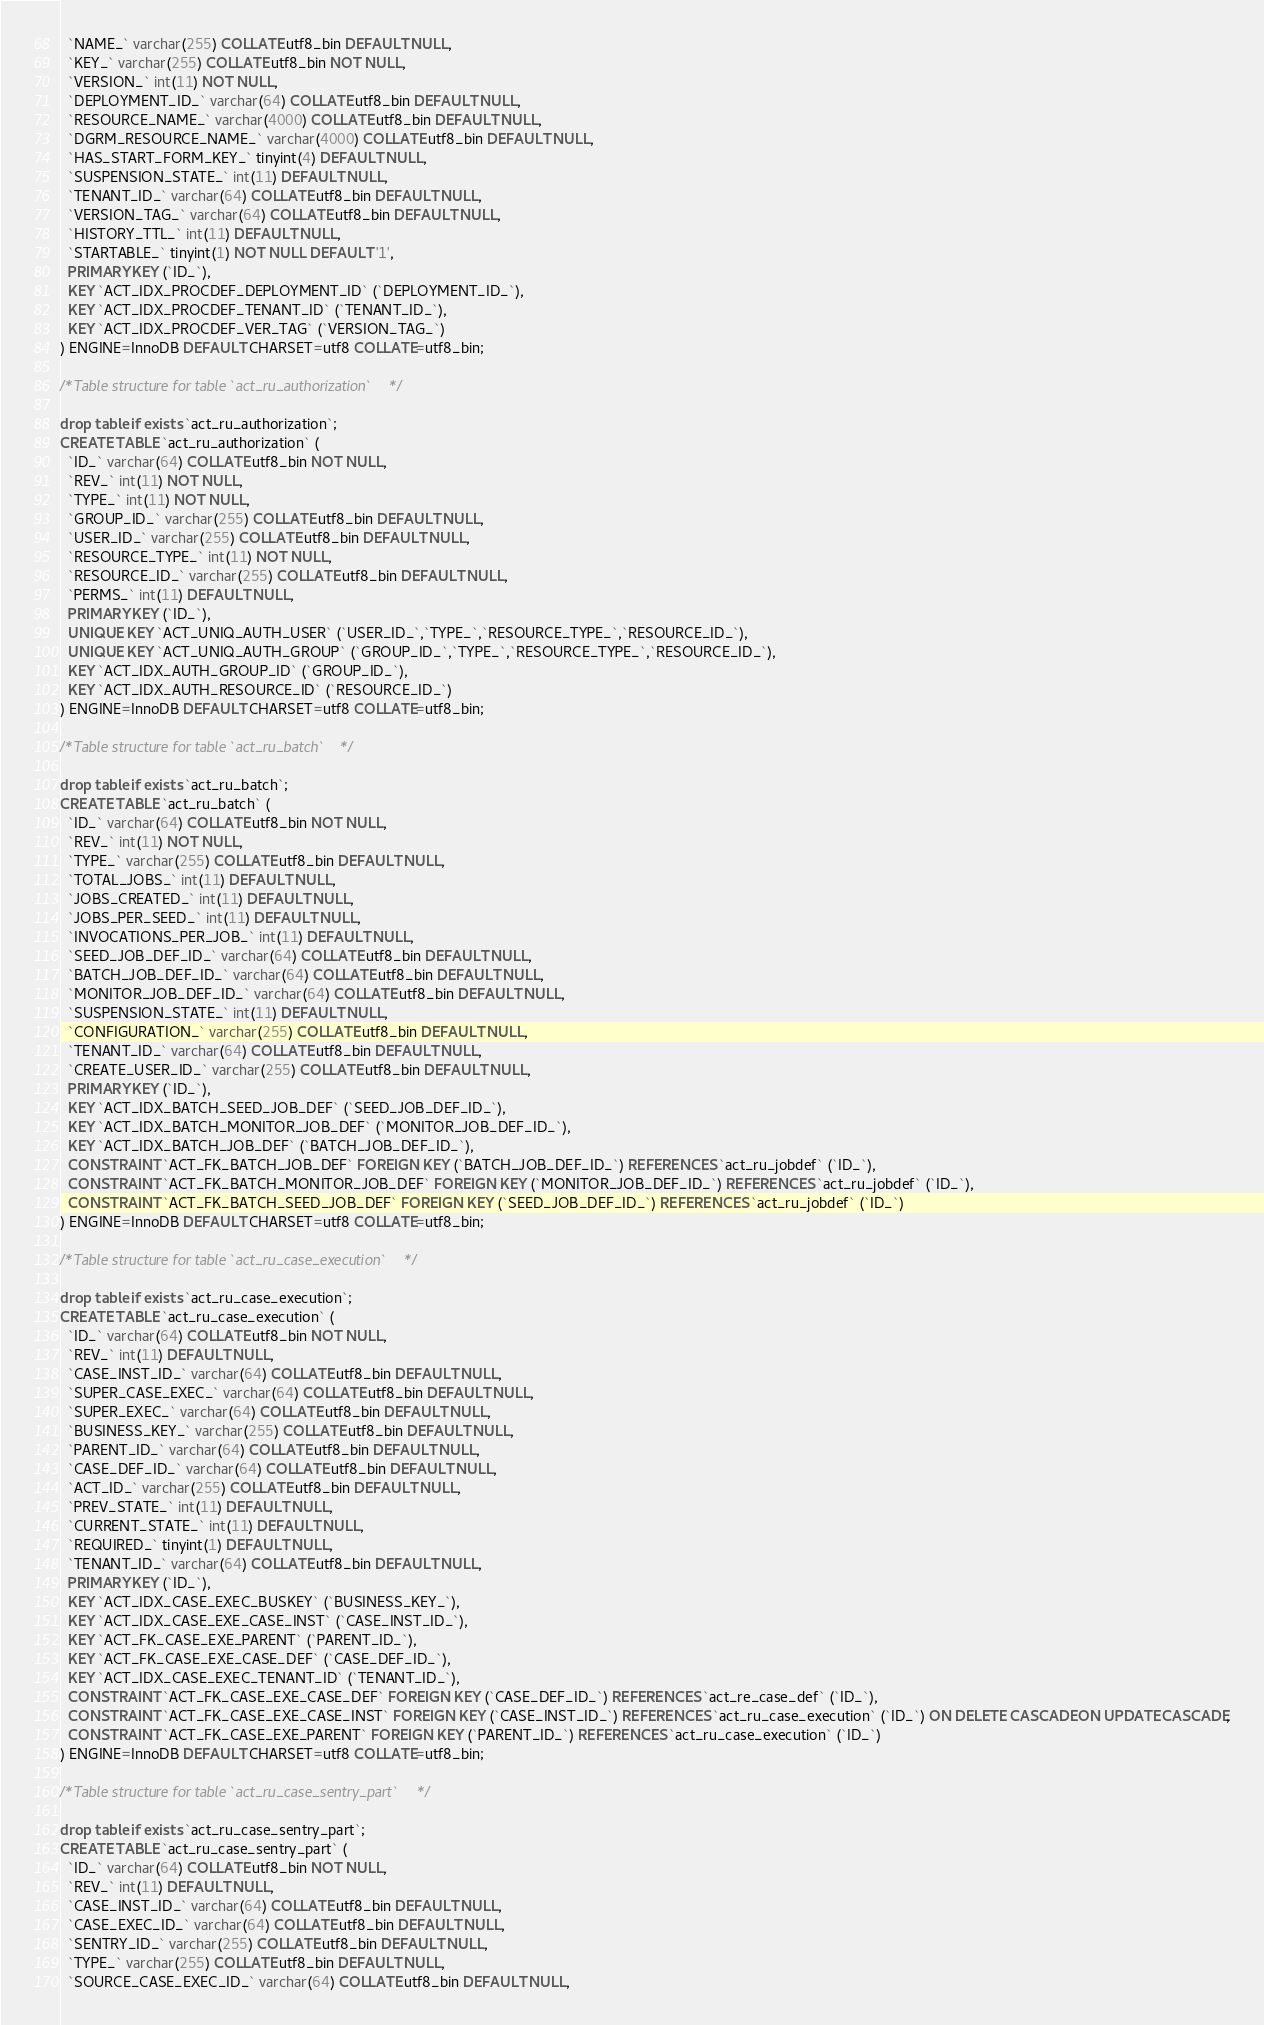Convert code to text. <code><loc_0><loc_0><loc_500><loc_500><_SQL_>  `NAME_` varchar(255) COLLATE utf8_bin DEFAULT NULL,
  `KEY_` varchar(255) COLLATE utf8_bin NOT NULL,
  `VERSION_` int(11) NOT NULL,
  `DEPLOYMENT_ID_` varchar(64) COLLATE utf8_bin DEFAULT NULL,
  `RESOURCE_NAME_` varchar(4000) COLLATE utf8_bin DEFAULT NULL,
  `DGRM_RESOURCE_NAME_` varchar(4000) COLLATE utf8_bin DEFAULT NULL,
  `HAS_START_FORM_KEY_` tinyint(4) DEFAULT NULL,
  `SUSPENSION_STATE_` int(11) DEFAULT NULL,
  `TENANT_ID_` varchar(64) COLLATE utf8_bin DEFAULT NULL,
  `VERSION_TAG_` varchar(64) COLLATE utf8_bin DEFAULT NULL,
  `HISTORY_TTL_` int(11) DEFAULT NULL,
  `STARTABLE_` tinyint(1) NOT NULL DEFAULT '1',
  PRIMARY KEY (`ID_`),
  KEY `ACT_IDX_PROCDEF_DEPLOYMENT_ID` (`DEPLOYMENT_ID_`),
  KEY `ACT_IDX_PROCDEF_TENANT_ID` (`TENANT_ID_`),
  KEY `ACT_IDX_PROCDEF_VER_TAG` (`VERSION_TAG_`)
) ENGINE=InnoDB DEFAULT CHARSET=utf8 COLLATE=utf8_bin;

/*Table structure for table `act_ru_authorization` */

drop table if exists `act_ru_authorization`;
CREATE TABLE `act_ru_authorization` (
  `ID_` varchar(64) COLLATE utf8_bin NOT NULL,
  `REV_` int(11) NOT NULL,
  `TYPE_` int(11) NOT NULL,
  `GROUP_ID_` varchar(255) COLLATE utf8_bin DEFAULT NULL,
  `USER_ID_` varchar(255) COLLATE utf8_bin DEFAULT NULL,
  `RESOURCE_TYPE_` int(11) NOT NULL,
  `RESOURCE_ID_` varchar(255) COLLATE utf8_bin DEFAULT NULL,
  `PERMS_` int(11) DEFAULT NULL,
  PRIMARY KEY (`ID_`),
  UNIQUE KEY `ACT_UNIQ_AUTH_USER` (`USER_ID_`,`TYPE_`,`RESOURCE_TYPE_`,`RESOURCE_ID_`),
  UNIQUE KEY `ACT_UNIQ_AUTH_GROUP` (`GROUP_ID_`,`TYPE_`,`RESOURCE_TYPE_`,`RESOURCE_ID_`),
  KEY `ACT_IDX_AUTH_GROUP_ID` (`GROUP_ID_`),
  KEY `ACT_IDX_AUTH_RESOURCE_ID` (`RESOURCE_ID_`)
) ENGINE=InnoDB DEFAULT CHARSET=utf8 COLLATE=utf8_bin;

/*Table structure for table `act_ru_batch` */

drop table if exists `act_ru_batch`;
CREATE TABLE `act_ru_batch` (
  `ID_` varchar(64) COLLATE utf8_bin NOT NULL,
  `REV_` int(11) NOT NULL,
  `TYPE_` varchar(255) COLLATE utf8_bin DEFAULT NULL,
  `TOTAL_JOBS_` int(11) DEFAULT NULL,
  `JOBS_CREATED_` int(11) DEFAULT NULL,
  `JOBS_PER_SEED_` int(11) DEFAULT NULL,
  `INVOCATIONS_PER_JOB_` int(11) DEFAULT NULL,
  `SEED_JOB_DEF_ID_` varchar(64) COLLATE utf8_bin DEFAULT NULL,
  `BATCH_JOB_DEF_ID_` varchar(64) COLLATE utf8_bin DEFAULT NULL,
  `MONITOR_JOB_DEF_ID_` varchar(64) COLLATE utf8_bin DEFAULT NULL,
  `SUSPENSION_STATE_` int(11) DEFAULT NULL,
  `CONFIGURATION_` varchar(255) COLLATE utf8_bin DEFAULT NULL,
  `TENANT_ID_` varchar(64) COLLATE utf8_bin DEFAULT NULL,
  `CREATE_USER_ID_` varchar(255) COLLATE utf8_bin DEFAULT NULL,
  PRIMARY KEY (`ID_`),
  KEY `ACT_IDX_BATCH_SEED_JOB_DEF` (`SEED_JOB_DEF_ID_`),
  KEY `ACT_IDX_BATCH_MONITOR_JOB_DEF` (`MONITOR_JOB_DEF_ID_`),
  KEY `ACT_IDX_BATCH_JOB_DEF` (`BATCH_JOB_DEF_ID_`),
  CONSTRAINT `ACT_FK_BATCH_JOB_DEF` FOREIGN KEY (`BATCH_JOB_DEF_ID_`) REFERENCES `act_ru_jobdef` (`ID_`),
  CONSTRAINT `ACT_FK_BATCH_MONITOR_JOB_DEF` FOREIGN KEY (`MONITOR_JOB_DEF_ID_`) REFERENCES `act_ru_jobdef` (`ID_`),
  CONSTRAINT `ACT_FK_BATCH_SEED_JOB_DEF` FOREIGN KEY (`SEED_JOB_DEF_ID_`) REFERENCES `act_ru_jobdef` (`ID_`)
) ENGINE=InnoDB DEFAULT CHARSET=utf8 COLLATE=utf8_bin;

/*Table structure for table `act_ru_case_execution` */

drop table if exists `act_ru_case_execution`;
CREATE TABLE `act_ru_case_execution` (
  `ID_` varchar(64) COLLATE utf8_bin NOT NULL,
  `REV_` int(11) DEFAULT NULL,
  `CASE_INST_ID_` varchar(64) COLLATE utf8_bin DEFAULT NULL,
  `SUPER_CASE_EXEC_` varchar(64) COLLATE utf8_bin DEFAULT NULL,
  `SUPER_EXEC_` varchar(64) COLLATE utf8_bin DEFAULT NULL,
  `BUSINESS_KEY_` varchar(255) COLLATE utf8_bin DEFAULT NULL,
  `PARENT_ID_` varchar(64) COLLATE utf8_bin DEFAULT NULL,
  `CASE_DEF_ID_` varchar(64) COLLATE utf8_bin DEFAULT NULL,
  `ACT_ID_` varchar(255) COLLATE utf8_bin DEFAULT NULL,
  `PREV_STATE_` int(11) DEFAULT NULL,
  `CURRENT_STATE_` int(11) DEFAULT NULL,
  `REQUIRED_` tinyint(1) DEFAULT NULL,
  `TENANT_ID_` varchar(64) COLLATE utf8_bin DEFAULT NULL,
  PRIMARY KEY (`ID_`),
  KEY `ACT_IDX_CASE_EXEC_BUSKEY` (`BUSINESS_KEY_`),
  KEY `ACT_IDX_CASE_EXE_CASE_INST` (`CASE_INST_ID_`),
  KEY `ACT_FK_CASE_EXE_PARENT` (`PARENT_ID_`),
  KEY `ACT_FK_CASE_EXE_CASE_DEF` (`CASE_DEF_ID_`),
  KEY `ACT_IDX_CASE_EXEC_TENANT_ID` (`TENANT_ID_`),
  CONSTRAINT `ACT_FK_CASE_EXE_CASE_DEF` FOREIGN KEY (`CASE_DEF_ID_`) REFERENCES `act_re_case_def` (`ID_`),
  CONSTRAINT `ACT_FK_CASE_EXE_CASE_INST` FOREIGN KEY (`CASE_INST_ID_`) REFERENCES `act_ru_case_execution` (`ID_`) ON DELETE CASCADE ON UPDATE CASCADE,
  CONSTRAINT `ACT_FK_CASE_EXE_PARENT` FOREIGN KEY (`PARENT_ID_`) REFERENCES `act_ru_case_execution` (`ID_`)
) ENGINE=InnoDB DEFAULT CHARSET=utf8 COLLATE=utf8_bin;

/*Table structure for table `act_ru_case_sentry_part` */

drop table if exists `act_ru_case_sentry_part`;
CREATE TABLE `act_ru_case_sentry_part` (
  `ID_` varchar(64) COLLATE utf8_bin NOT NULL,
  `REV_` int(11) DEFAULT NULL,
  `CASE_INST_ID_` varchar(64) COLLATE utf8_bin DEFAULT NULL,
  `CASE_EXEC_ID_` varchar(64) COLLATE utf8_bin DEFAULT NULL,
  `SENTRY_ID_` varchar(255) COLLATE utf8_bin DEFAULT NULL,
  `TYPE_` varchar(255) COLLATE utf8_bin DEFAULT NULL,
  `SOURCE_CASE_EXEC_ID_` varchar(64) COLLATE utf8_bin DEFAULT NULL,</code> 